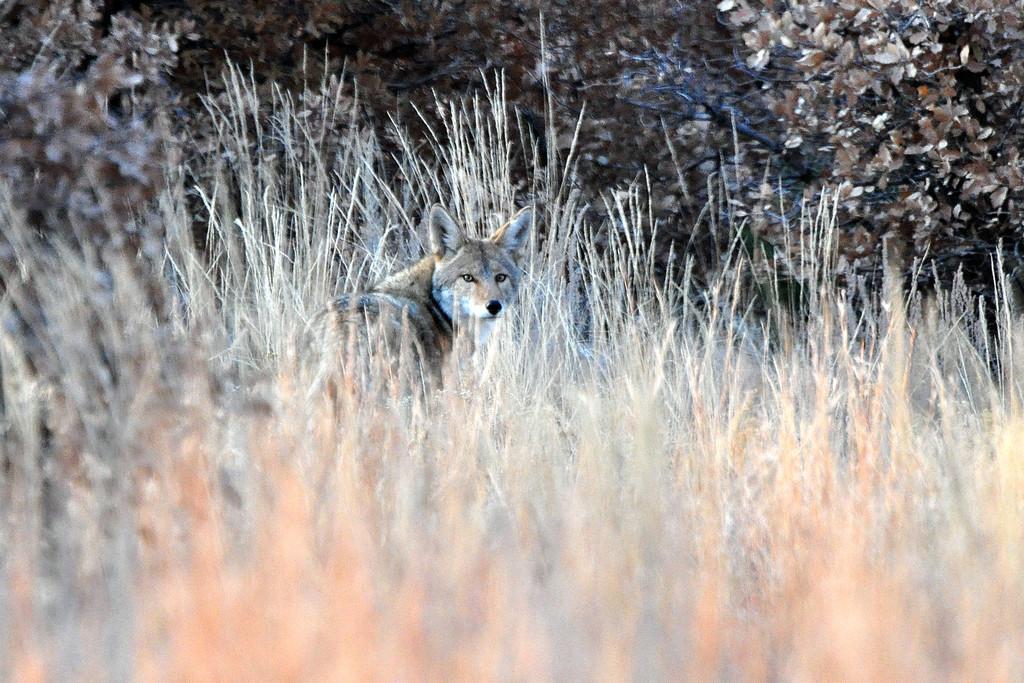Can you describe this image briefly? In this image I can see an animal which is in white and brown color. It is in-between the dried grass. To the side I can see many trees. 